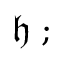<formula> <loc_0><loc_0><loc_500><loc_500>{ \mathfrak { h } } ;</formula> 